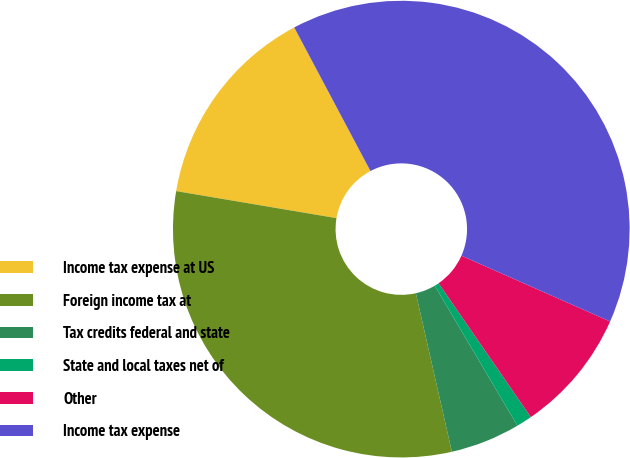<chart> <loc_0><loc_0><loc_500><loc_500><pie_chart><fcel>Income tax expense at US<fcel>Foreign income tax at<fcel>Tax credits federal and state<fcel>State and local taxes net of<fcel>Other<fcel>Income tax expense<nl><fcel>14.57%<fcel>31.22%<fcel>4.94%<fcel>1.11%<fcel>8.77%<fcel>39.4%<nl></chart> 